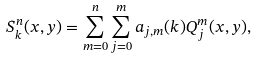Convert formula to latex. <formula><loc_0><loc_0><loc_500><loc_500>S _ { k } ^ { n } ( x , y ) = \sum _ { m = 0 } ^ { n } \sum _ { j = 0 } ^ { m } a _ { j , m } ( k ) Q _ { j } ^ { m } ( x , y ) ,</formula> 